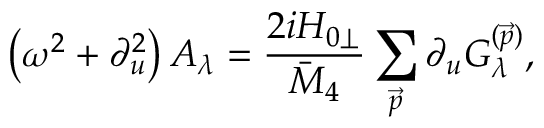<formula> <loc_0><loc_0><loc_500><loc_500>\left ( \omega ^ { 2 } + \partial _ { u } ^ { 2 } \right ) A _ { \lambda } = \frac { 2 i H _ { 0 \perp } } { \bar { M } _ { 4 } } \sum _ { \vec { p } } \partial _ { u } G _ { \lambda } ^ { ( \vec { p } ) } ,</formula> 